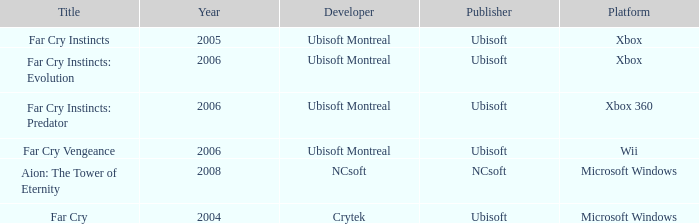Which title has xbox as the platform with a year prior to 2006? Far Cry Instincts. 